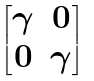<formula> <loc_0><loc_0><loc_500><loc_500>\begin{bmatrix} \gamma & 0 \\ 0 & \gamma \end{bmatrix}</formula> 